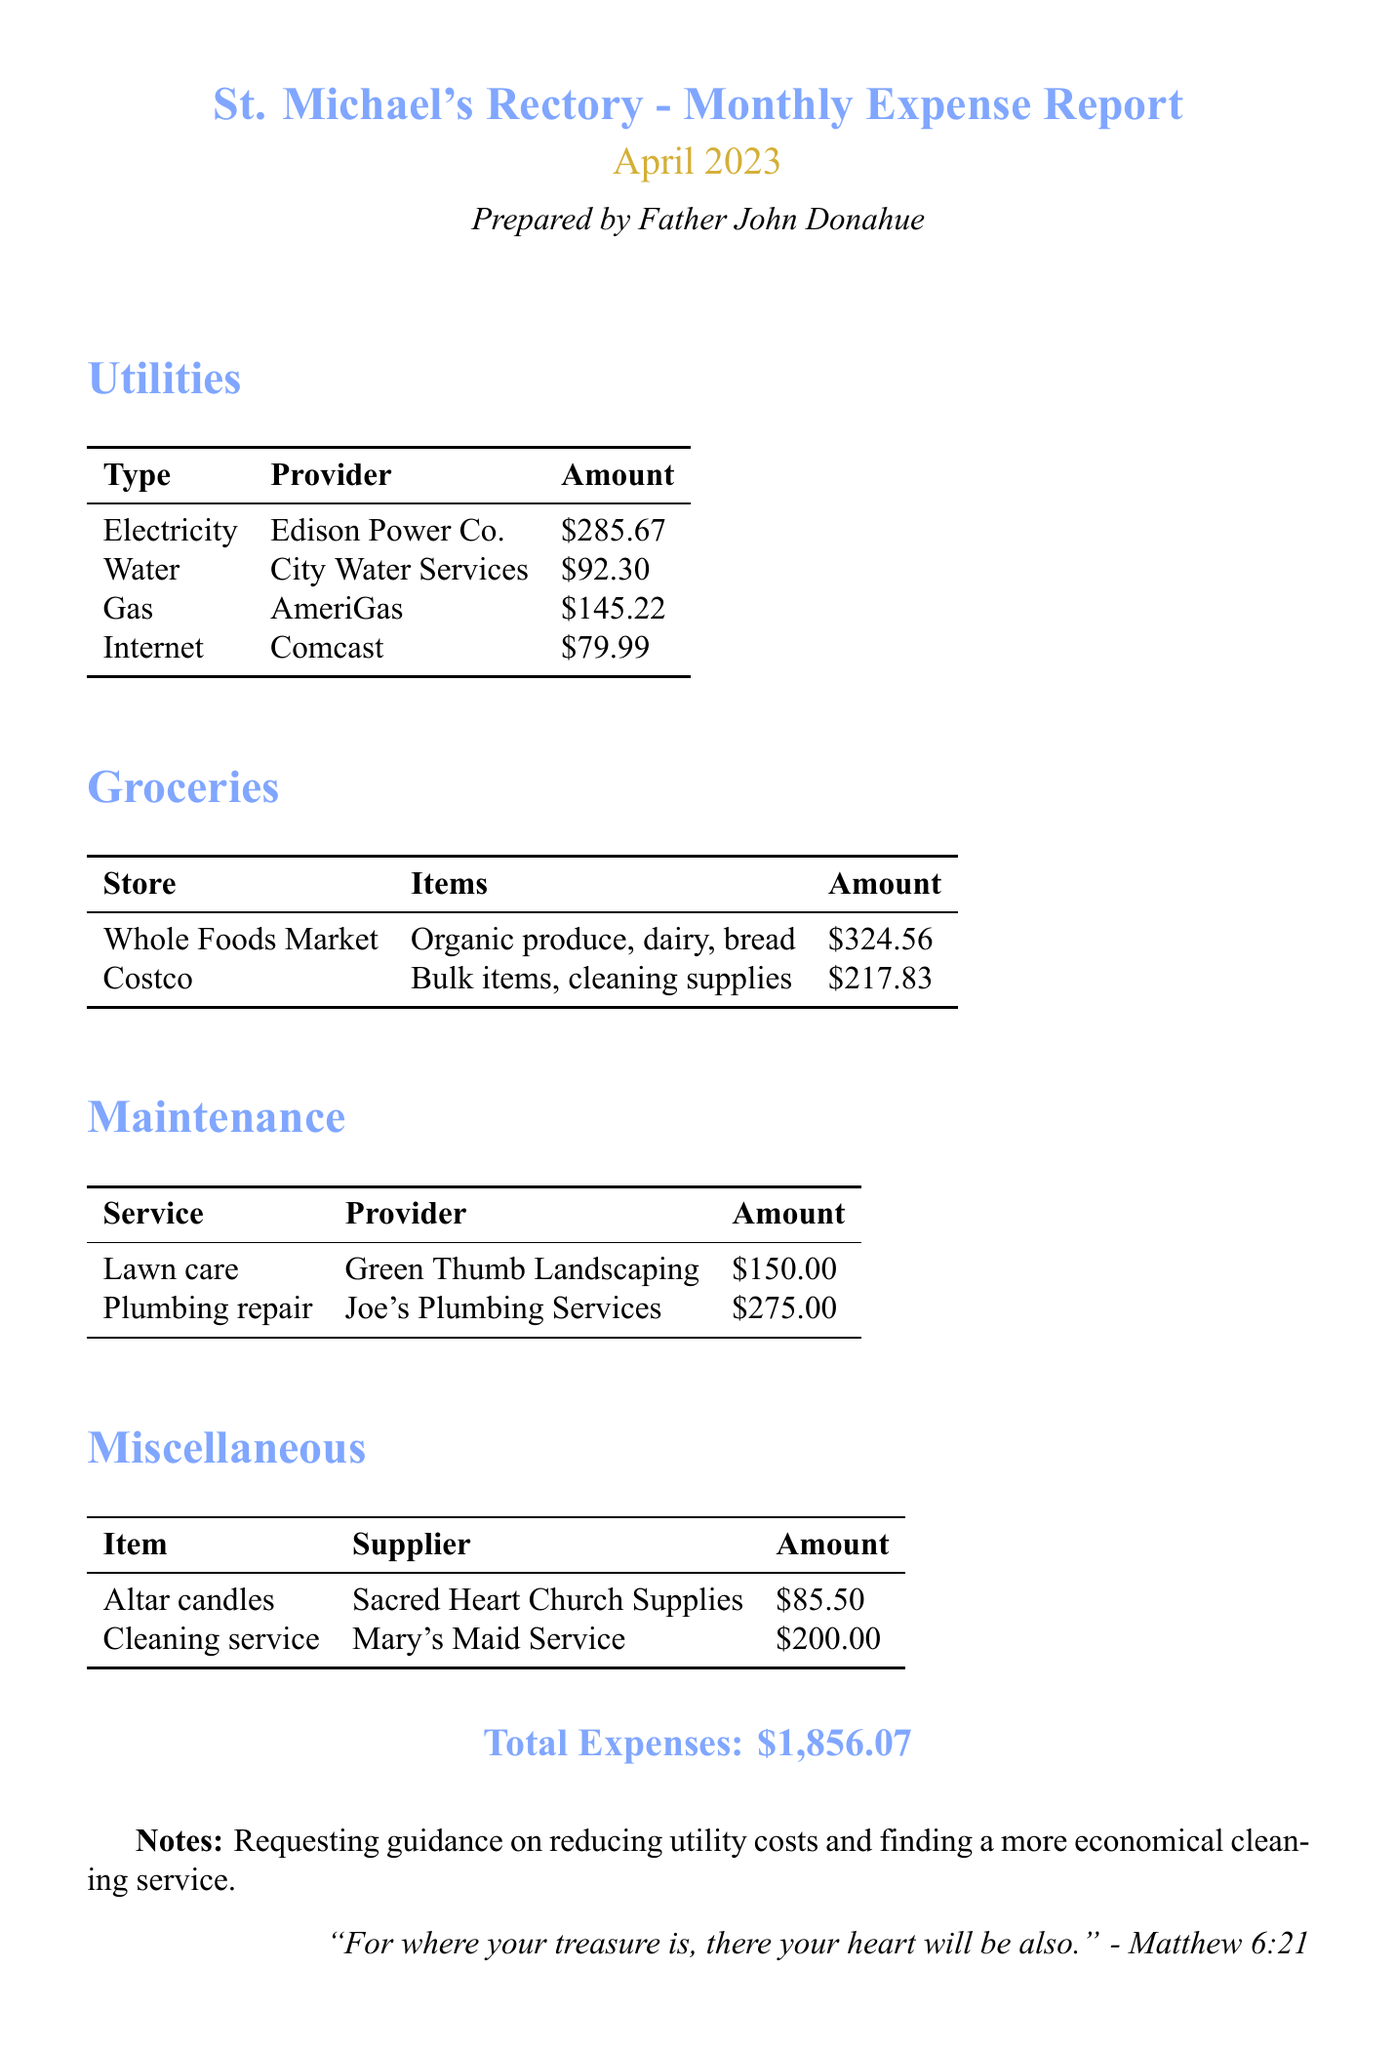what is the title of the report? The title is stated clearly at the top of the document.
Answer: St. Michael's Rectory - Monthly Expense Report who prepared the report? The document specifies who the report was prepared by.
Answer: Father John Donahue what was the amount spent on groceries? The total sum of all grocery expenses listed in the document provides this information.
Answer: $542.39 how much was spent on electricity? The document lists the individual utility costs, including electricity.
Answer: $285.67 which service provider was used for plumbing repair? The document names the company that provided the plumbing service.
Answer: Joe's Plumbing Services what are the total expenses for April 2023? The total expenses are summarized at the end of the report.
Answer: $1,856.07 what item was purchased from Sacred Heart Church Supplies? The miscellaneous section of the document lists items and their suppliers.
Answer: Altar candles which store was the largest grocery expenditure at? By comparing the amounts spent at each grocery store, we find the largest expense.
Answer: Whole Foods Market what notes are included in the report? There is a notes section at the bottom of the report detailing specific requests.
Answer: Requesting guidance on reducing utility costs and finding a more economical cleaning service 